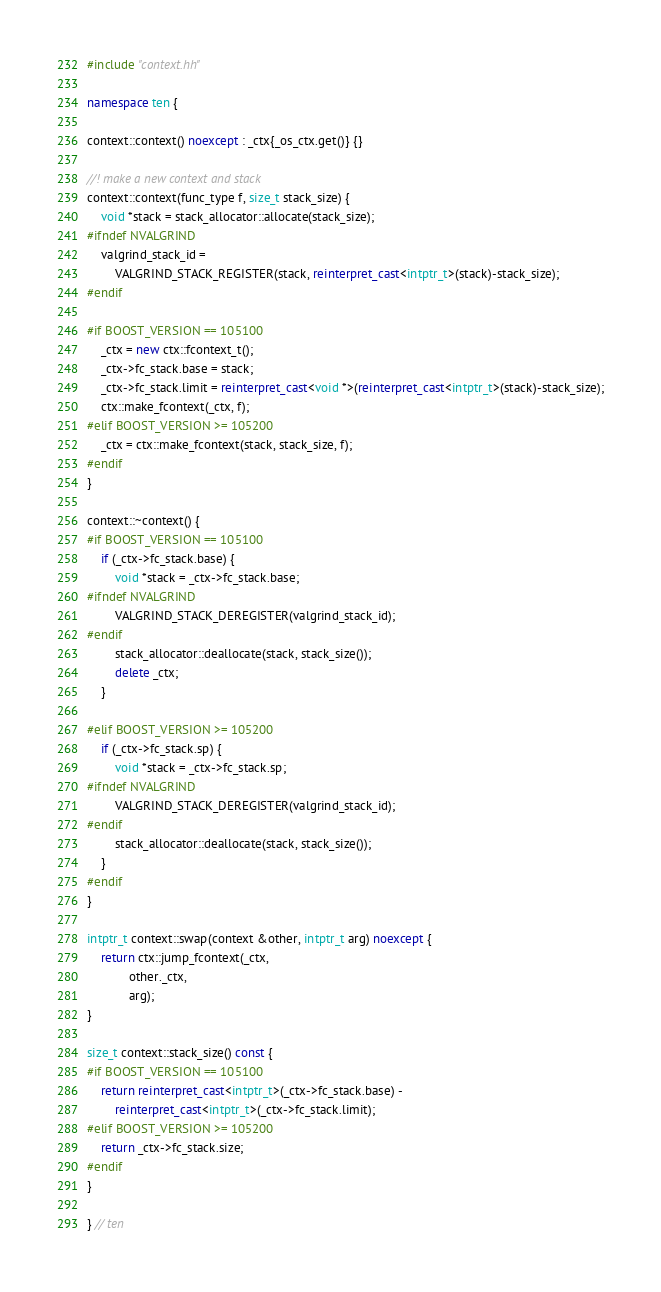Convert code to text. <code><loc_0><loc_0><loc_500><loc_500><_C++_>#include "context.hh"

namespace ten {

context::context() noexcept : _ctx{_os_ctx.get()} {}

//! make a new context and stack
context::context(func_type f, size_t stack_size) {
    void *stack = stack_allocator::allocate(stack_size);
#ifndef NVALGRIND
    valgrind_stack_id =
        VALGRIND_STACK_REGISTER(stack, reinterpret_cast<intptr_t>(stack)-stack_size);
#endif

#if BOOST_VERSION == 105100
    _ctx = new ctx::fcontext_t();
    _ctx->fc_stack.base = stack;
    _ctx->fc_stack.limit = reinterpret_cast<void *>(reinterpret_cast<intptr_t>(stack)-stack_size);
    ctx::make_fcontext(_ctx, f);
#elif BOOST_VERSION >= 105200
    _ctx = ctx::make_fcontext(stack, stack_size, f);
#endif
}

context::~context() {
#if BOOST_VERSION == 105100
    if (_ctx->fc_stack.base) {
        void *stack = _ctx->fc_stack.base;
#ifndef NVALGRIND
        VALGRIND_STACK_DEREGISTER(valgrind_stack_id);
#endif
        stack_allocator::deallocate(stack, stack_size());
        delete _ctx;
    }

#elif BOOST_VERSION >= 105200
    if (_ctx->fc_stack.sp) {
        void *stack = _ctx->fc_stack.sp;
#ifndef NVALGRIND
        VALGRIND_STACK_DEREGISTER(valgrind_stack_id);
#endif
        stack_allocator::deallocate(stack, stack_size());
    }
#endif
}

intptr_t context::swap(context &other, intptr_t arg) noexcept {
    return ctx::jump_fcontext(_ctx,
            other._ctx,
            arg);
}

size_t context::stack_size() const {
#if BOOST_VERSION == 105100
    return reinterpret_cast<intptr_t>(_ctx->fc_stack.base) -
        reinterpret_cast<intptr_t>(_ctx->fc_stack.limit);
#elif BOOST_VERSION >= 105200
    return _ctx->fc_stack.size;
#endif
}

} // ten
</code> 